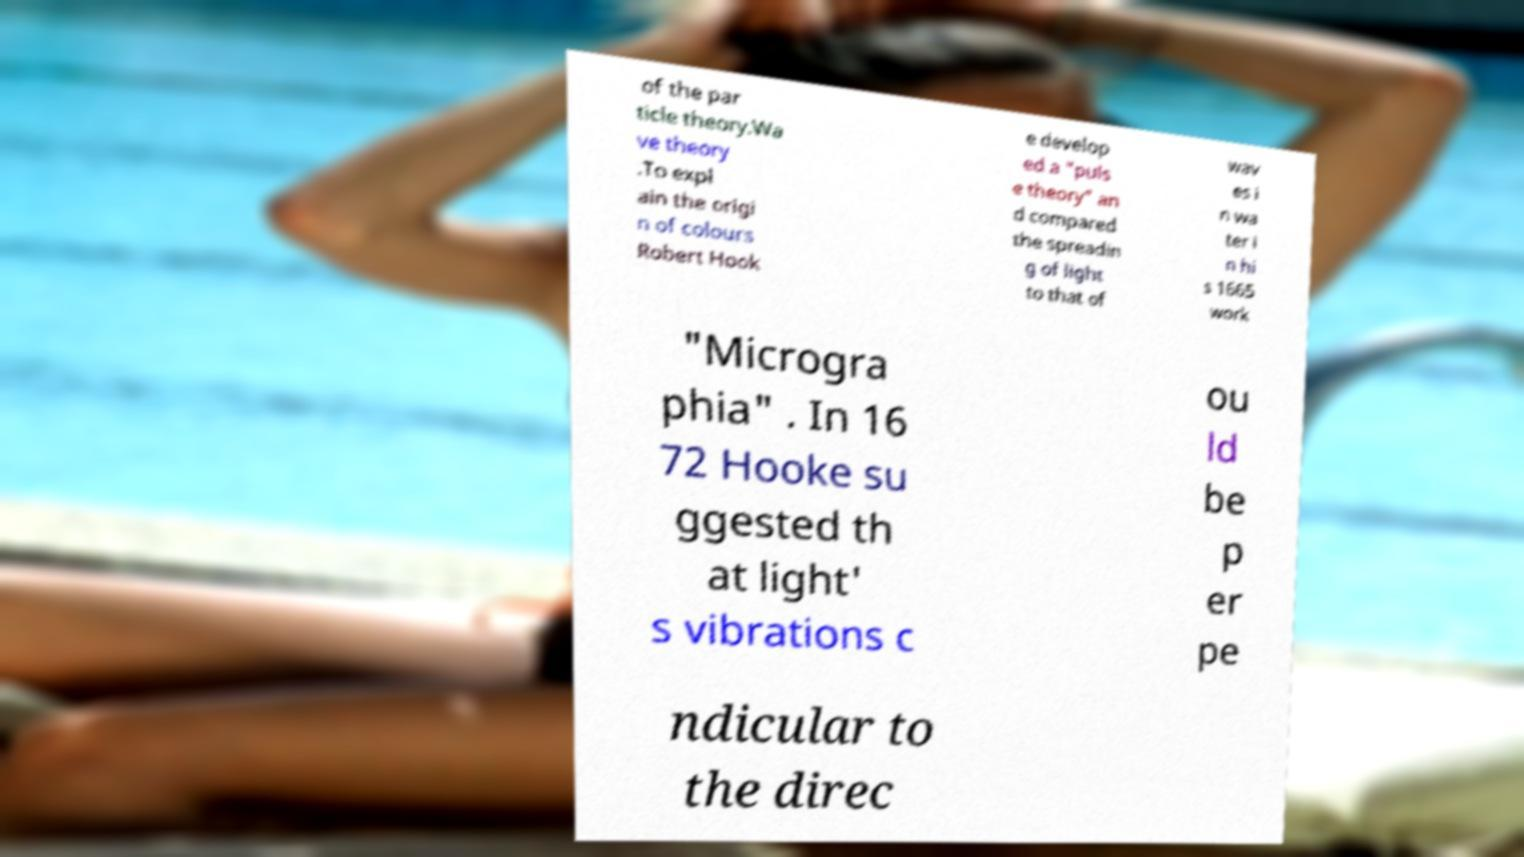There's text embedded in this image that I need extracted. Can you transcribe it verbatim? of the par ticle theory.Wa ve theory .To expl ain the origi n of colours Robert Hook e develop ed a "puls e theory" an d compared the spreadin g of light to that of wav es i n wa ter i n hi s 1665 work "Microgra phia" . In 16 72 Hooke su ggested th at light' s vibrations c ou ld be p er pe ndicular to the direc 